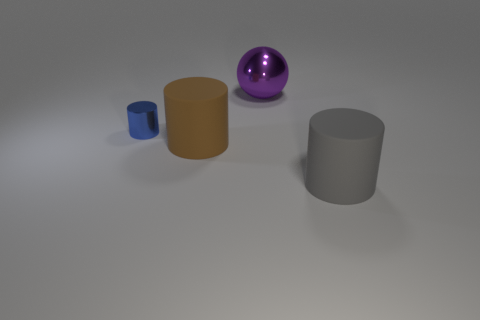Is there any other thing that is the same size as the blue cylinder?
Your answer should be compact. No. What material is the gray object that is the same size as the purple metallic thing?
Offer a very short reply. Rubber. There is a big object that is both in front of the ball and behind the large gray matte thing; what shape is it?
Give a very brief answer. Cylinder. The other metallic thing that is the same size as the gray thing is what color?
Ensure brevity in your answer.  Purple. Do the metallic thing that is to the right of the blue cylinder and the rubber cylinder left of the purple metal thing have the same size?
Provide a succinct answer. Yes. What size is the metal thing on the right side of the rubber object behind the large rubber object that is on the right side of the ball?
Ensure brevity in your answer.  Large. There is a big rubber thing that is left of the object behind the small cylinder; what is its shape?
Offer a terse response. Cylinder. Does the cylinder that is to the right of the purple object have the same color as the large metallic sphere?
Your answer should be compact. No. There is a large object that is on the left side of the gray rubber thing and in front of the purple object; what color is it?
Your answer should be very brief. Brown. Are there any gray things that have the same material as the blue cylinder?
Provide a succinct answer. No. 